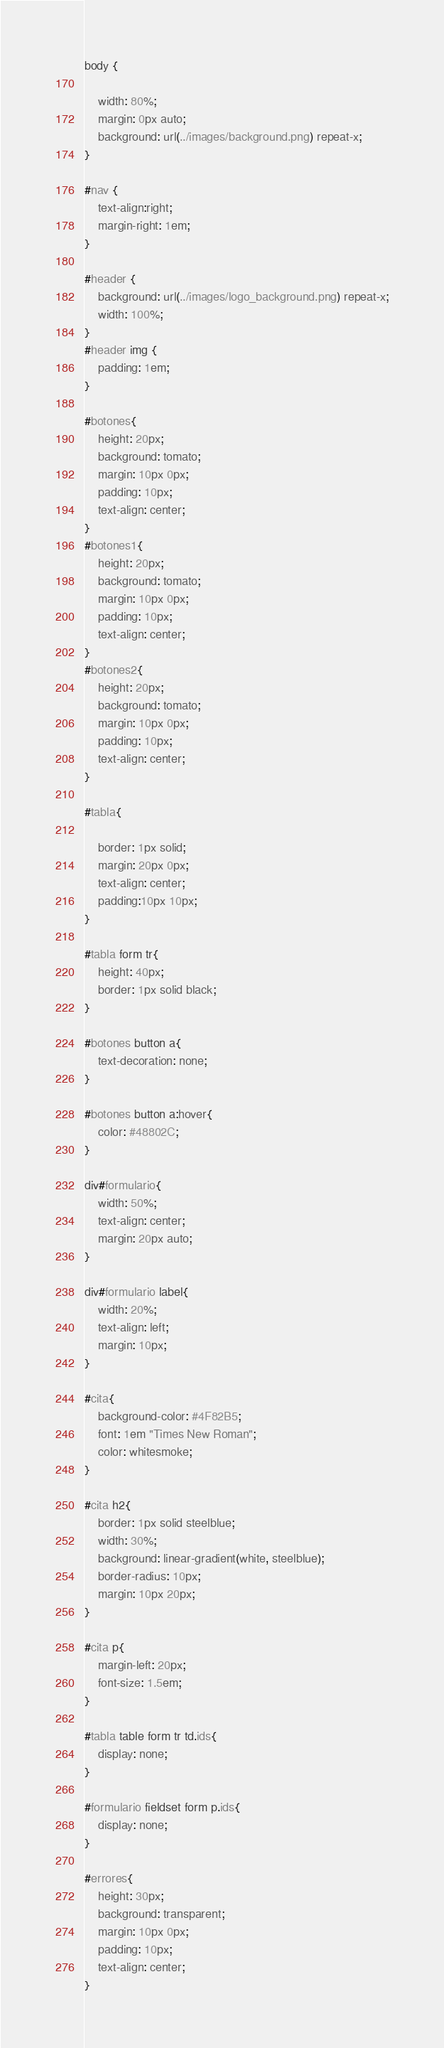Convert code to text. <code><loc_0><loc_0><loc_500><loc_500><_CSS_>body {

    width: 80%;
    margin: 0px auto;
    background: url(../images/background.png) repeat-x;
}

#nav {
    text-align:right;
    margin-right: 1em;
}

#header {
    background: url(../images/logo_background.png) repeat-x;
    width: 100%;
}
#header img {
    padding: 1em;
}

#botones{
    height: 20px;
    background: tomato;
    margin: 10px 0px;
    padding: 10px;
    text-align: center;
}
#botones1{
    height: 20px;
    background: tomato;
    margin: 10px 0px;
    padding: 10px;
    text-align: center;
}
#botones2{
    height: 20px;
    background: tomato;
    margin: 10px 0px;
    padding: 10px;
    text-align: center;
}

#tabla{

    border: 1px solid;
    margin: 20px 0px;
    text-align: center;
    padding:10px 10px;
}

#tabla form tr{
    height: 40px;
    border: 1px solid black;
}

#botones button a{
    text-decoration: none;
}

#botones button a:hover{
    color: #48802C;
}

div#formulario{
    width: 50%;
    text-align: center;
    margin: 20px auto;
}

div#formulario label{
    width: 20%;
    text-align: left;
    margin: 10px;
}

#cita{
    background-color: #4F82B5;
    font: 1em "Times New Roman";
    color: whitesmoke;
}

#cita h2{
    border: 1px solid steelblue;
    width: 30%;
    background: linear-gradient(white, steelblue);
    border-radius: 10px;
    margin: 10px 20px;
}

#cita p{
    margin-left: 20px;
    font-size: 1.5em;
}

#tabla table form tr td.ids{
    display: none;
}

#formulario fieldset form p.ids{
    display: none;
}

#errores{
    height: 30px;
    background: transparent;
    margin: 10px 0px;
    padding: 10px;
    text-align: center;
}

</code> 